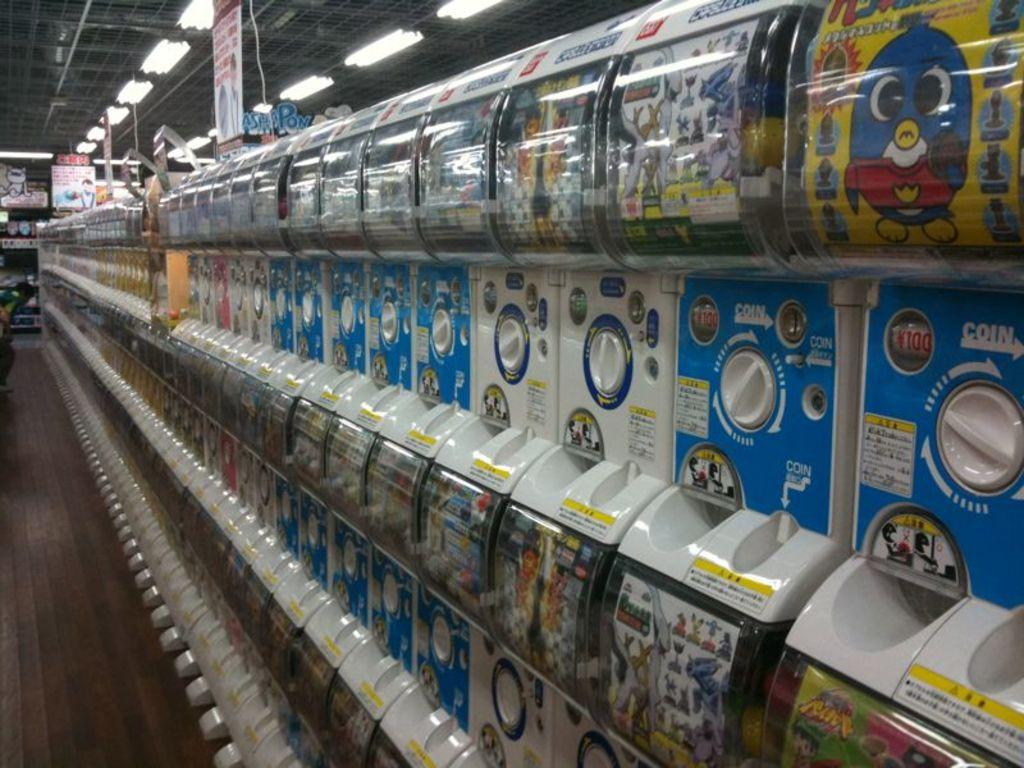<image>
Describe the image concisely. A series of toy machines that show which direction to insert a coin. 